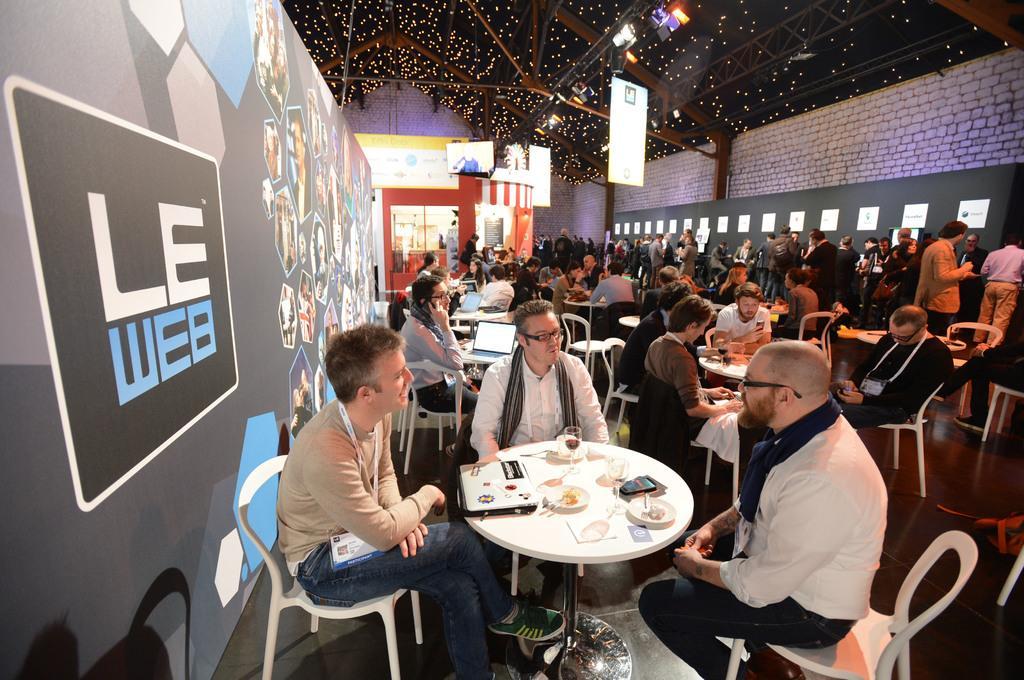Can you describe this image briefly? This is the picture of a place where we have some people sitting on the chairs around the table on which there are some things and also we can see some lights. 